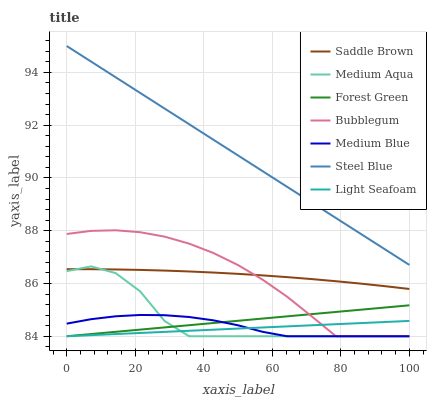Does Bubblegum have the minimum area under the curve?
Answer yes or no. No. Does Bubblegum have the maximum area under the curve?
Answer yes or no. No. Is Steel Blue the smoothest?
Answer yes or no. No. Is Steel Blue the roughest?
Answer yes or no. No. Does Steel Blue have the lowest value?
Answer yes or no. No. Does Bubblegum have the highest value?
Answer yes or no. No. Is Saddle Brown less than Steel Blue?
Answer yes or no. Yes. Is Steel Blue greater than Bubblegum?
Answer yes or no. Yes. Does Saddle Brown intersect Steel Blue?
Answer yes or no. No. 